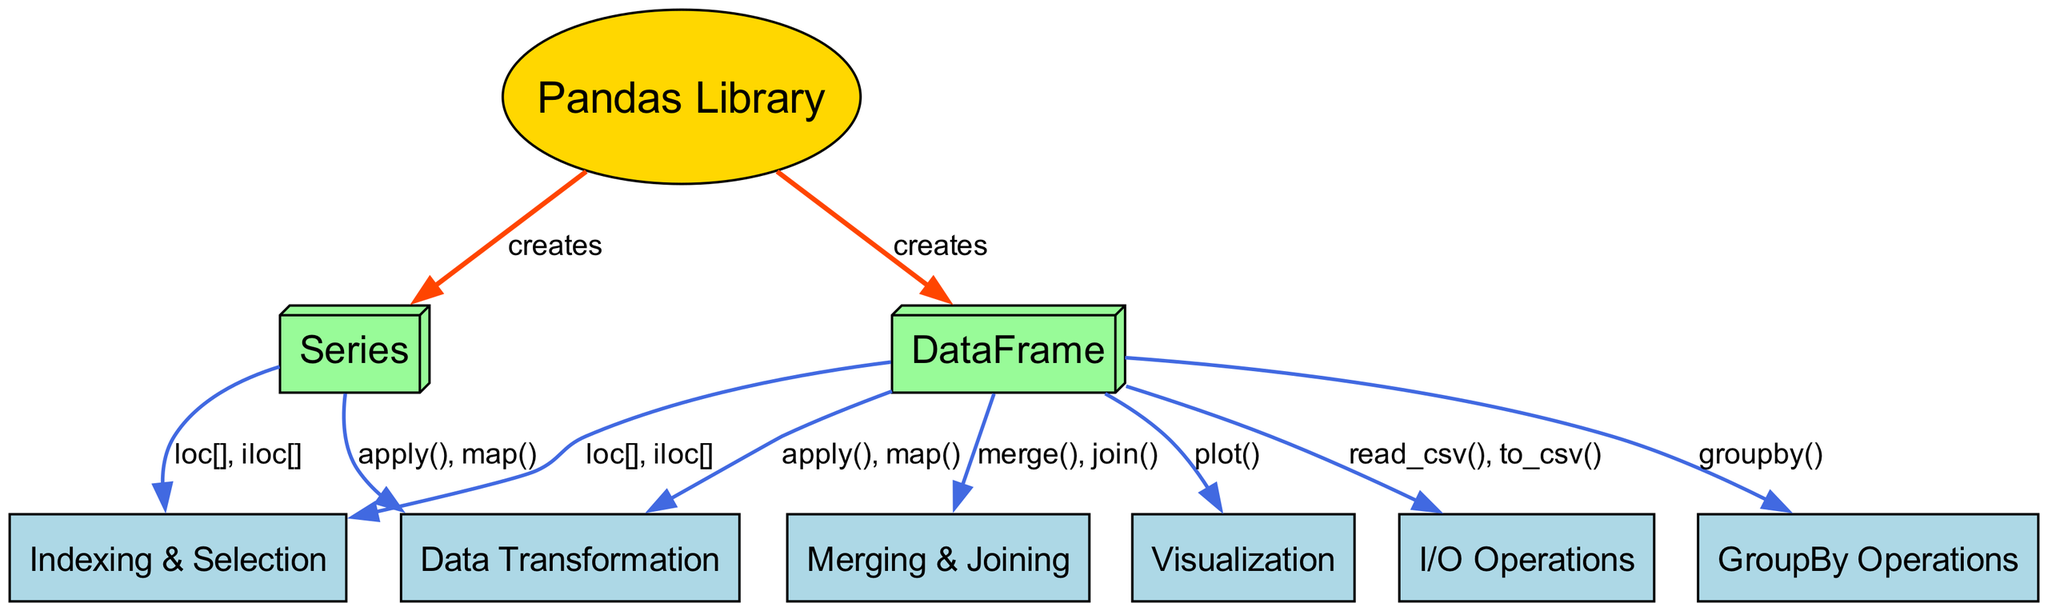What is the primary function of the pandas library? The pandas library is primarily for data manipulation and analysis in Python. It facilitates working with structured data using its core data structures like DataFrame and Series.
Answer: Data manipulation and analysis How many nodes are present in the concept map? By counting the nodes listed in the provided data, we find there are eight nodes, including the pandas library, DataFrame, Series, I/O operations, indexing & selection, GroupBy operations, merging & joining, data transformation, and visualization.
Answer: 8 What relationship does the DataFrame have with I/O operations? The relationship between DataFrame and I/O operations is represented by the functions read_csv() and to_csv(), indicating that a DataFrame can be created from a CSV file and can also be saved to a CSV file.
Answer: read_csv(), to_csv() Which core pandas functionality is responsible for statistical grouping of data? The GroupBy operations functionality is responsible for statistical grouping of data within a DataFrame, allowing the application of aggregate functions on subsets of the data based on certain conditions.
Answer: GroupBy operations What are the two methods used for indexing and selecting data from a DataFrame? The two methods used for indexing and selecting data from a DataFrame are loc[] and iloc[]. These methods allow users to access data by label and by position, respectively.
Answer: loc[], iloc[] How many edges connect the DataFrame to other functionalities? The DataFrame is connected to six other functionalities through edges representing various operations, including I/O, indexing, groupby, merging, transforming, and visualization.
Answer: 6 Which two methods link Series to data transformation? The Series can use the methods apply() and map() for data transformation, which allows applying a function to data or mapping values to new values within the Series.
Answer: apply(), map() What is the connection between merging and joining with the DataFrame? The merging and joining operations allow for combining two or more DataFrames based on common columns or indices, enabling the analysis of data dispersed across multiple sources.
Answer: merge(), join() What type of node is the 'Pandas Library' identified as in the concept map? The 'Pandas Library' is identified as an ellipse shape in the concept map, indicating its fundamental role as the main library around which the other data structures and operations are centered.
Answer: ellipse 